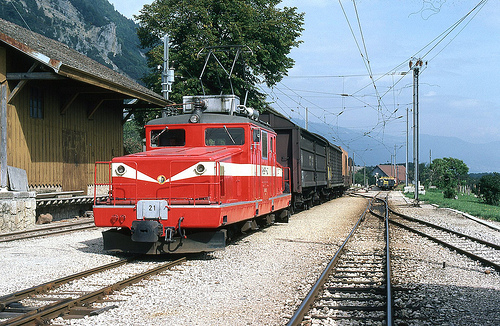Which kind of vehicle is to the left of the cars? To the left of the freight cars is a red locomotive, integral for the movement of these railcars. 